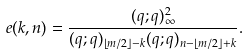<formula> <loc_0><loc_0><loc_500><loc_500>e ( k , n ) = \frac { ( q ; q ) _ { \infty } ^ { 2 } } { ( q ; q ) _ { \left \lfloor m / 2 \right \rfloor - k } ( q ; q ) _ { n - \left \lfloor m / 2 \right \rfloor + k } } .</formula> 